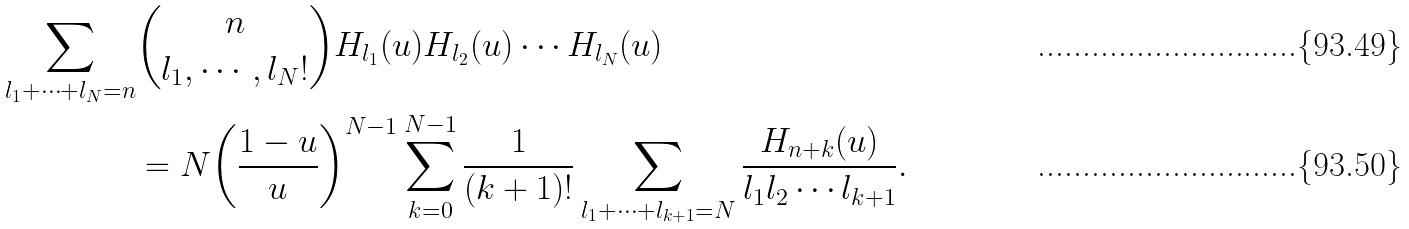Convert formula to latex. <formula><loc_0><loc_0><loc_500><loc_500>\sum _ { l _ { 1 } + \cdots + l _ { N } = n } & \binom { n } { l _ { 1 } , \cdots , l _ { N } ! } H _ { l _ { 1 } } ( u ) H _ { l _ { 2 } } ( u ) \cdots H _ { l _ { N } } ( u ) \\ & = N { \left ( \frac { 1 - u } { u } \right ) } ^ { N - 1 } \sum _ { k = 0 } ^ { N - 1 } \frac { 1 } { ( k + 1 ) ! } \sum _ { l _ { 1 } + \cdots + l _ { k + 1 } = N } \frac { H _ { n + k } ( u ) } { l _ { 1 } l _ { 2 } \cdots l _ { k + 1 } } .</formula> 